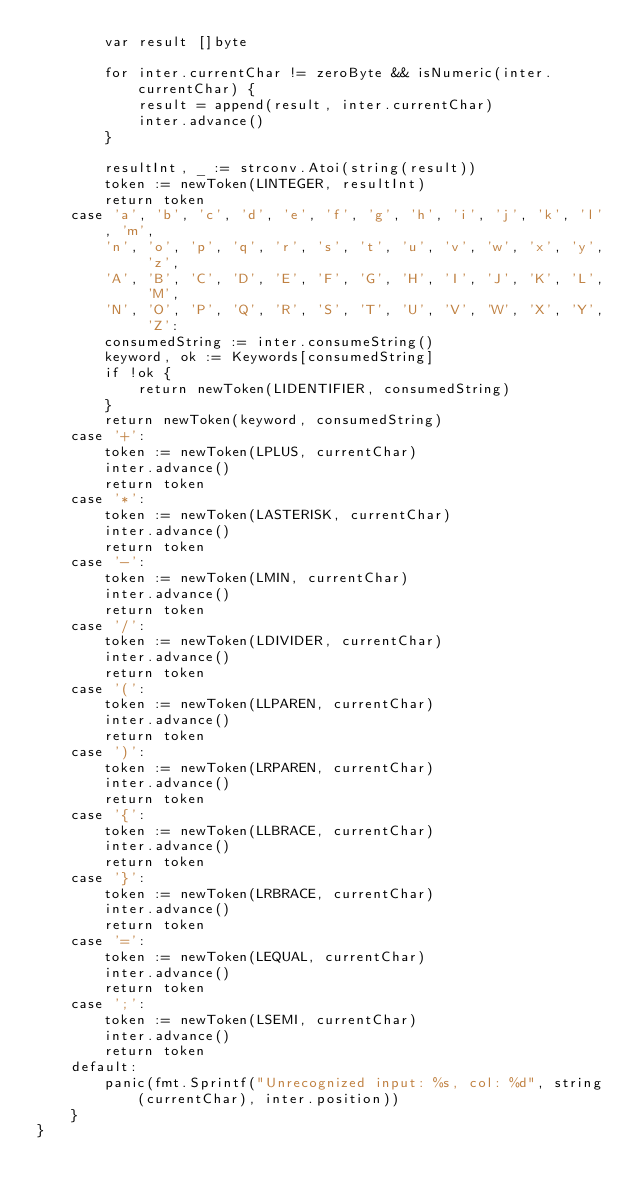Convert code to text. <code><loc_0><loc_0><loc_500><loc_500><_Go_>		var result []byte

		for inter.currentChar != zeroByte && isNumeric(inter.currentChar) {
			result = append(result, inter.currentChar)
			inter.advance()
		}

		resultInt, _ := strconv.Atoi(string(result))
		token := newToken(LINTEGER, resultInt)
		return token
	case 'a', 'b', 'c', 'd', 'e', 'f', 'g', 'h', 'i', 'j', 'k', 'l', 'm',
		'n', 'o', 'p', 'q', 'r', 's', 't', 'u', 'v', 'w', 'x', 'y', 'z',
		'A', 'B', 'C', 'D', 'E', 'F', 'G', 'H', 'I', 'J', 'K', 'L', 'M',
		'N', 'O', 'P', 'Q', 'R', 'S', 'T', 'U', 'V', 'W', 'X', 'Y', 'Z':
		consumedString := inter.consumeString()
		keyword, ok := Keywords[consumedString]
		if !ok {
			return newToken(LIDENTIFIER, consumedString)
		}
		return newToken(keyword, consumedString)
	case '+':
		token := newToken(LPLUS, currentChar)
		inter.advance()
		return token
	case '*':
		token := newToken(LASTERISK, currentChar)
		inter.advance()
		return token
	case '-':
		token := newToken(LMIN, currentChar)
		inter.advance()
		return token
	case '/':
		token := newToken(LDIVIDER, currentChar)
		inter.advance()
		return token
	case '(':
		token := newToken(LLPAREN, currentChar)
		inter.advance()
		return token
	case ')':
		token := newToken(LRPAREN, currentChar)
		inter.advance()
		return token
	case '{':
		token := newToken(LLBRACE, currentChar)
		inter.advance()
		return token
	case '}':
		token := newToken(LRBRACE, currentChar)
		inter.advance()
		return token
	case '=':
		token := newToken(LEQUAL, currentChar)
		inter.advance()
		return token
	case ';':
		token := newToken(LSEMI, currentChar)
		inter.advance()
		return token
	default:
		panic(fmt.Sprintf("Unrecognized input: %s, col: %d", string(currentChar), inter.position))
	}
}
</code> 